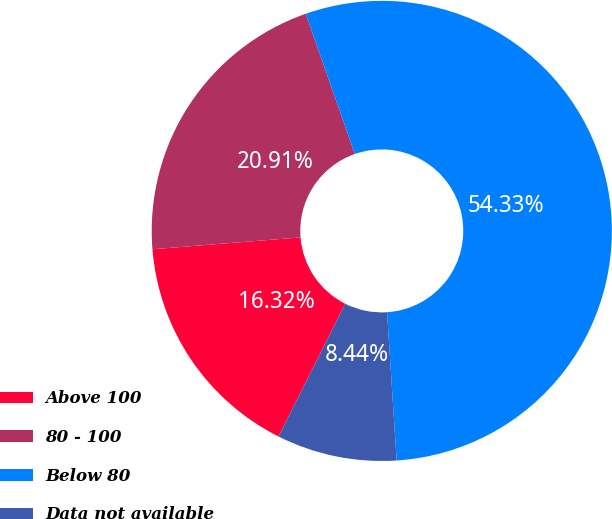<chart> <loc_0><loc_0><loc_500><loc_500><pie_chart><fcel>Above 100<fcel>80 - 100<fcel>Below 80<fcel>Data not available<nl><fcel>16.32%<fcel>20.91%<fcel>54.33%<fcel>8.44%<nl></chart> 